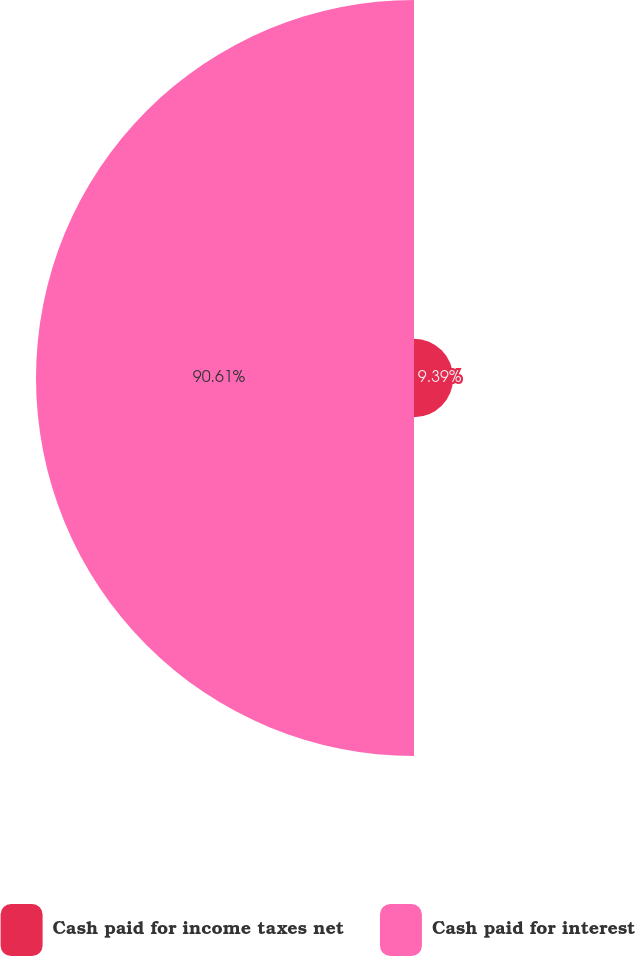Convert chart to OTSL. <chart><loc_0><loc_0><loc_500><loc_500><pie_chart><fcel>Cash paid for income taxes net<fcel>Cash paid for interest<nl><fcel>9.39%<fcel>90.61%<nl></chart> 